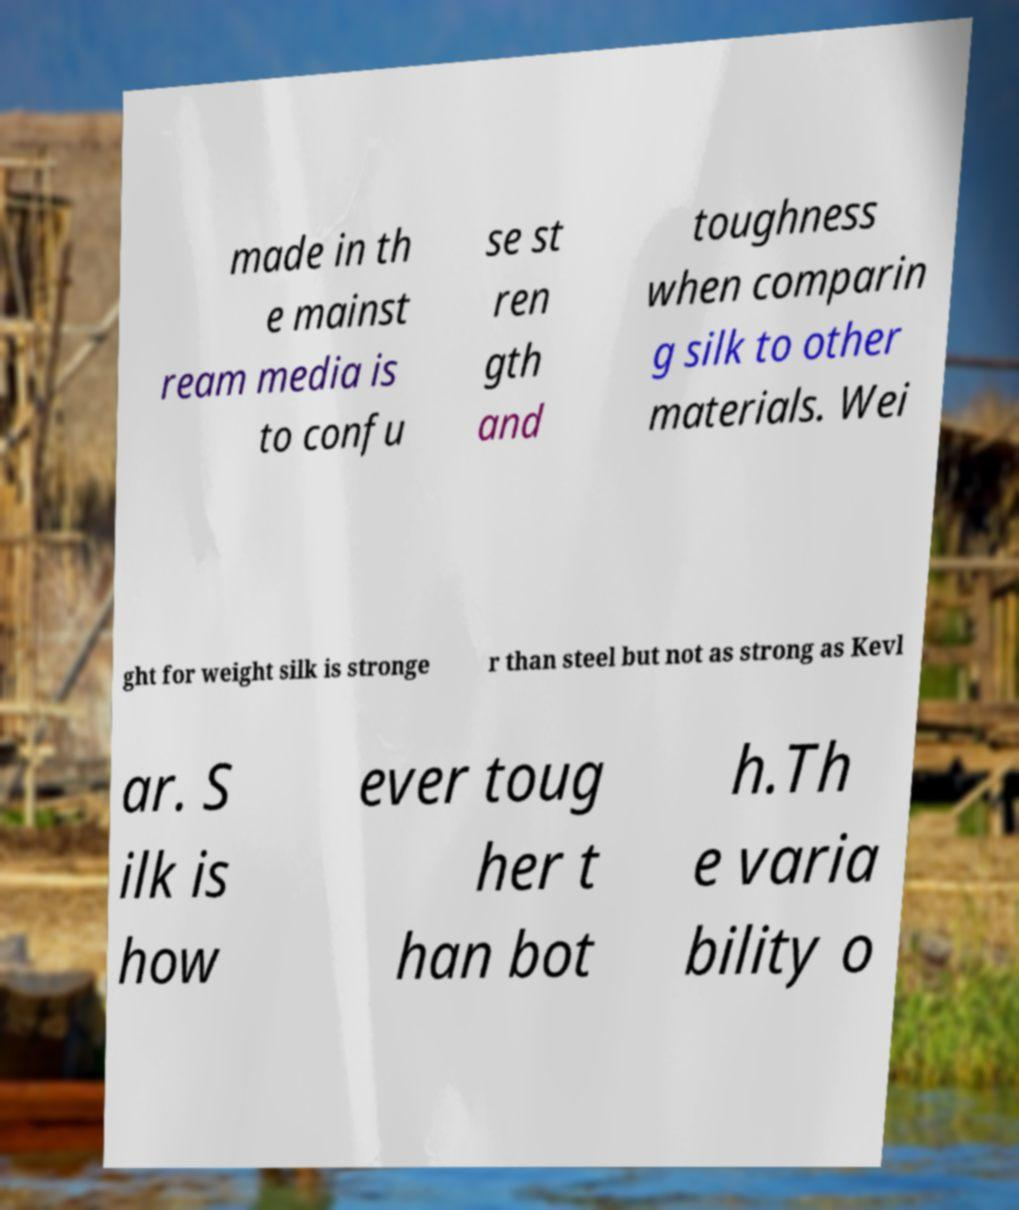There's text embedded in this image that I need extracted. Can you transcribe it verbatim? made in th e mainst ream media is to confu se st ren gth and toughness when comparin g silk to other materials. Wei ght for weight silk is stronge r than steel but not as strong as Kevl ar. S ilk is how ever toug her t han bot h.Th e varia bility o 